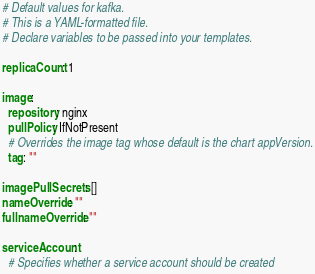Convert code to text. <code><loc_0><loc_0><loc_500><loc_500><_YAML_># Default values for kafka.
# This is a YAML-formatted file.
# Declare variables to be passed into your templates.

replicaCount: 1

image:
  repository: nginx
  pullPolicy: IfNotPresent
  # Overrides the image tag whose default is the chart appVersion.
  tag: ""

imagePullSecrets: []
nameOverride: ""
fullnameOverride: ""

serviceAccount:
  # Specifies whether a service account should be created</code> 